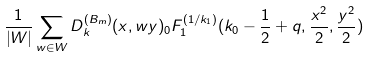<formula> <loc_0><loc_0><loc_500><loc_500>\frac { 1 } { | W | } \sum _ { w \in W } D _ { k } ^ { ( B _ { m } ) } ( x , w y ) _ { 0 } F _ { 1 } ^ { ( 1 / k _ { 1 } ) } ( k _ { 0 } - \frac { 1 } { 2 } + q , \frac { x ^ { 2 } } { 2 } , \frac { y ^ { 2 } } { 2 } )</formula> 